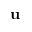Convert formula to latex. <formula><loc_0><loc_0><loc_500><loc_500>u</formula> 